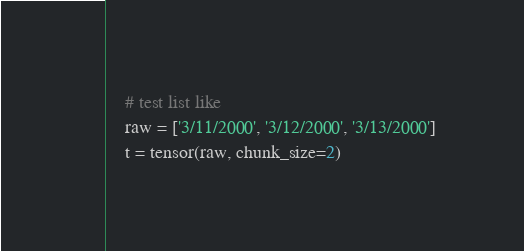Convert code to text. <code><loc_0><loc_0><loc_500><loc_500><_Python_>    # test list like
    raw = ['3/11/2000', '3/12/2000', '3/13/2000']
    t = tensor(raw, chunk_size=2)</code> 